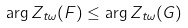Convert formula to latex. <formula><loc_0><loc_0><loc_500><loc_500>\arg Z _ { t \omega } ( F ) \leq \arg Z _ { t \omega } ( G )</formula> 